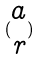Convert formula to latex. <formula><loc_0><loc_0><loc_500><loc_500>( \begin{matrix} a \\ r \end{matrix} )</formula> 